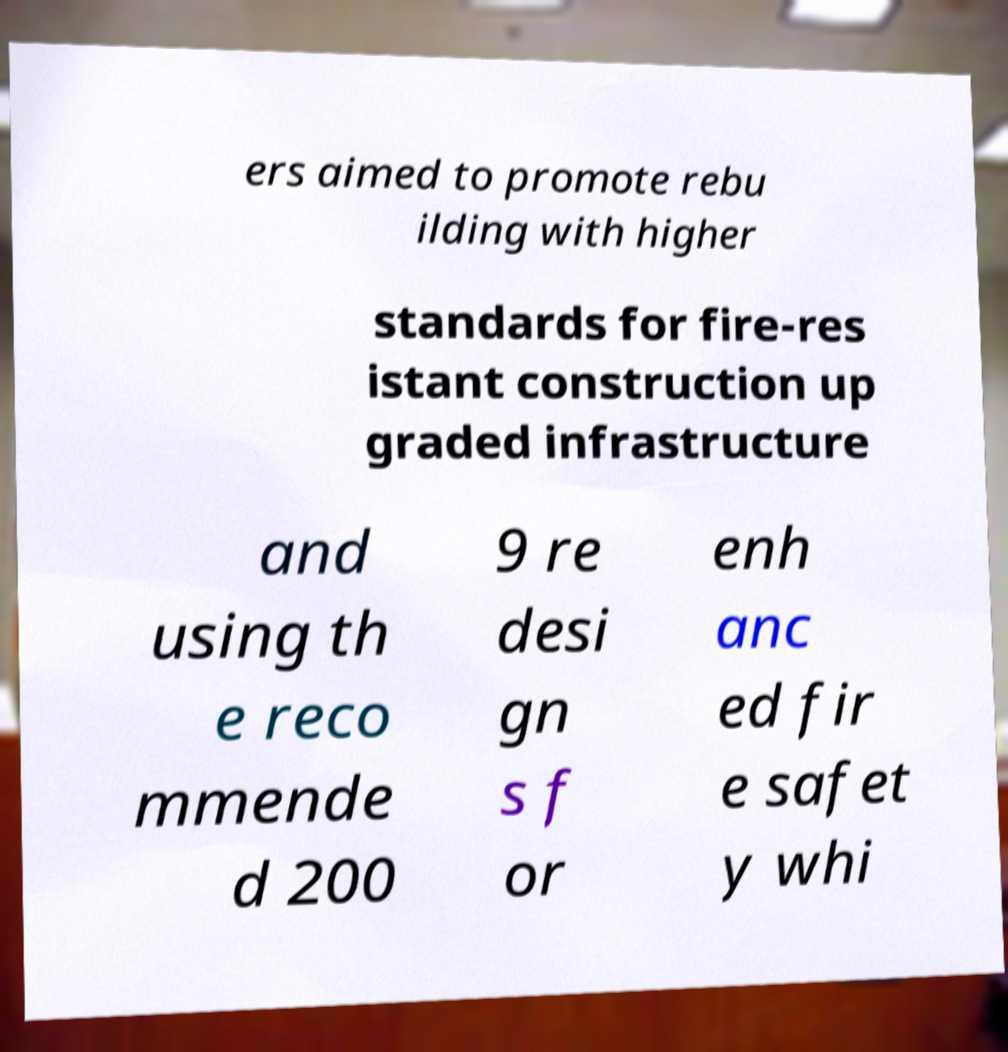There's text embedded in this image that I need extracted. Can you transcribe it verbatim? ers aimed to promote rebu ilding with higher standards for fire-res istant construction up graded infrastructure and using th e reco mmende d 200 9 re desi gn s f or enh anc ed fir e safet y whi 